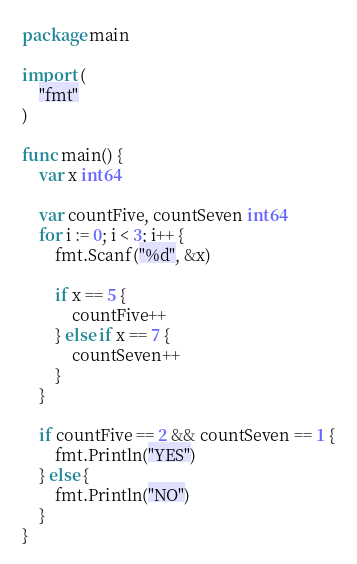Convert code to text. <code><loc_0><loc_0><loc_500><loc_500><_Go_>package main

import (
	"fmt"
)

func main() {
	var x int64

	var countFive, countSeven int64
	for i := 0; i < 3; i++ {
		fmt.Scanf("%d", &x)

		if x == 5 {
			countFive++
		} else if x == 7 {
			countSeven++
		}
	}

	if countFive == 2 && countSeven == 1 {
		fmt.Println("YES")
	} else {
		fmt.Println("NO")
	}
}
</code> 